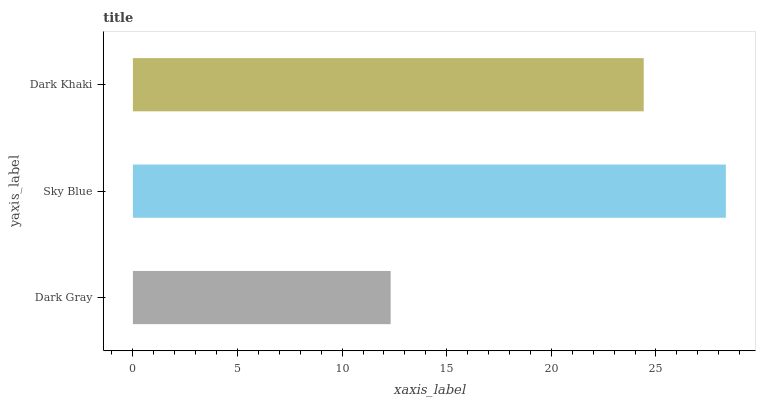Is Dark Gray the minimum?
Answer yes or no. Yes. Is Sky Blue the maximum?
Answer yes or no. Yes. Is Dark Khaki the minimum?
Answer yes or no. No. Is Dark Khaki the maximum?
Answer yes or no. No. Is Sky Blue greater than Dark Khaki?
Answer yes or no. Yes. Is Dark Khaki less than Sky Blue?
Answer yes or no. Yes. Is Dark Khaki greater than Sky Blue?
Answer yes or no. No. Is Sky Blue less than Dark Khaki?
Answer yes or no. No. Is Dark Khaki the high median?
Answer yes or no. Yes. Is Dark Khaki the low median?
Answer yes or no. Yes. Is Dark Gray the high median?
Answer yes or no. No. Is Sky Blue the low median?
Answer yes or no. No. 